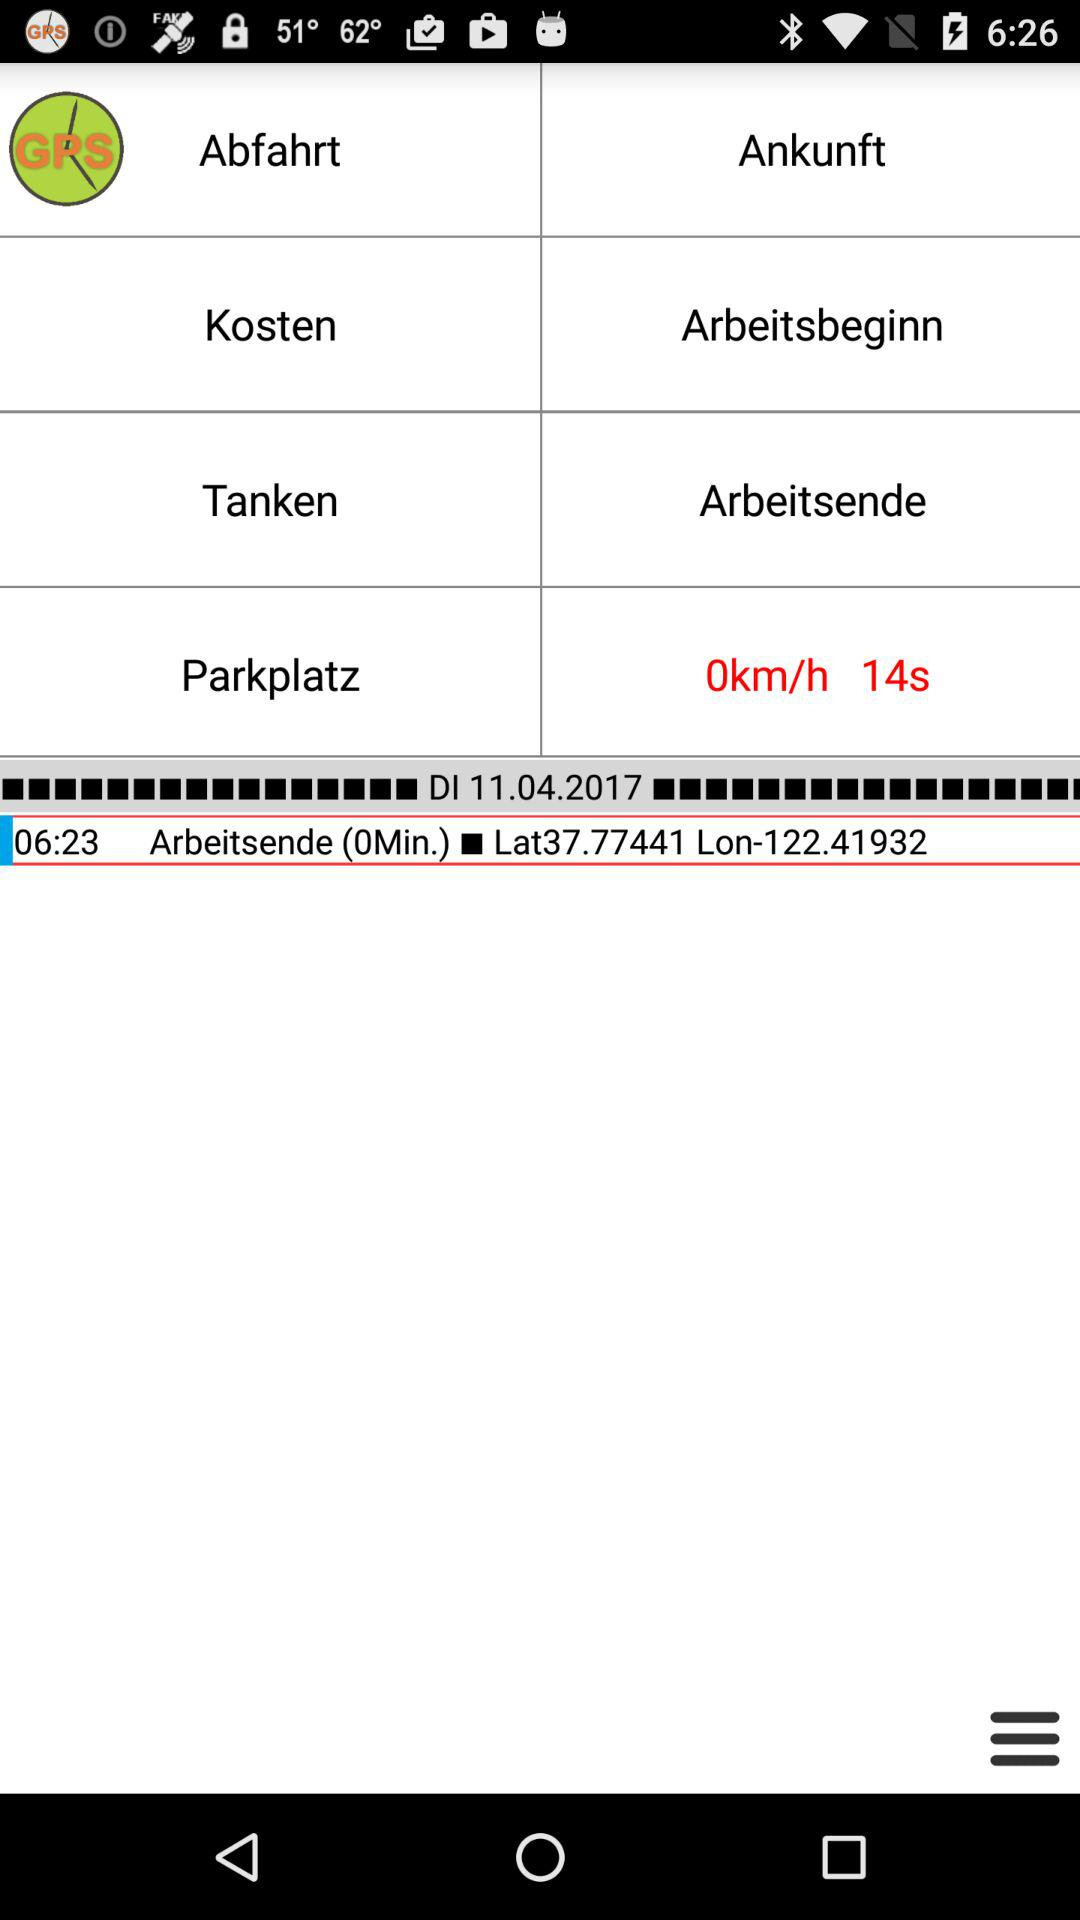What is the latitude and longitude of the destination?
Answer the question using a single word or phrase. Lat37.77441 Lon-122.41932 